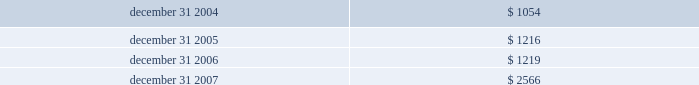Certain options to purchase shares of devon 2019s common stock were excluded from the dilution calculations because the options were antidilutive .
These excluded options totaled 2 million , 3 million and 0.2 million in 2007 , 2006 and 2005 , respectively .
Foreign currency translation adjustments the u.s .
Dollar is the functional currency for devon 2019s consolidated operations except its canadian subsidiaries , which use the canadian dollar as the functional currency .
Therefore , the assets and liabilities of devon 2019s canadian subsidiaries are translated into u.s .
Dollars based on the current exchange rate in effect at the balance sheet dates .
Canadian income and expenses are translated at average rates for the periods presented .
Translation adjustments have no effect on net income and are included in accumulated other comprehensive income in stockholders 2019 equity .
The table presents the balances of devon 2019s cumulative translation adjustments included in accumulated other comprehensive income ( in millions ) . .
Statements of cash flows for purposes of the consolidated statements of cash flows , devon considers all highly liquid investments with original contractual maturities of three months or less to be cash equivalents .
Commitments and contingencies liabilities for loss contingencies arising from claims , assessments , litigation or other sources are recorded when it is probable that a liability has been incurred and the amount can be reasonably estimated .
Liabilities for environmental remediation or restoration claims are recorded when it is probable that obligations have been incurred and the amounts can be reasonably estimated .
Expenditures related to such environmental matters are expensed or capitalized in accordance with devon 2019s accounting policy for property and equipment .
Reference is made to note 8 for a discussion of amounts recorded for these liabilities .
Recently issued accounting standards not yet adopted in december 2007 , the financial accounting standards board ( 201cfasb 201d ) issued statement of financial accounting standards no .
141 ( r ) , business combinations , which replaces statement no .
141 .
Statement no .
141 ( r ) retains the fundamental requirements of statement no .
141 that an acquirer be identified and the acquisition method of accounting ( previously called the purchase method ) be used for all business combinations .
Statement no .
141 ( r ) 2019s scope is broader than that of statement no .
141 , which applied only to business combinations in which control was obtained by transferring consideration .
By applying the acquisition method to all transactions and other events in which one entity obtains control over one or more other businesses , statement no .
141 ( r ) improves the comparability of the information about business combinations provided in financial reports .
Statement no .
141 ( r ) establishes principles and requirements for how an acquirer recognizes and measures identifiable assets acquired , liabilities assumed and any noncontrolling interest in the acquiree , as well as any resulting goodwill .
Statement no .
141 ( r ) applies prospectively to business combinations for which the acquisition date is on or after the beginning of the first annual reporting period beginning on or after december 15 , 2008 .
Devon will evaluate how the new requirements of statement no .
141 ( r ) would impact any business combinations completed in 2009 or thereafter .
In december 2007 , the fasb also issued statement of financial accounting standards no .
160 , noncontrolling interests in consolidated financial statements 2014an amendment of accounting research bulletin no .
51 .
A noncontrolling interest , sometimes called a minority interest , is the portion of equity in a subsidiary not attributable , directly or indirectly , to a parent .
Statement no .
160 establishes accounting and reporting standards for the noncontrolling interest in a subsidiary and for the deconsolidation of a subsidiary .
Under statement no .
160 , noncontrolling interests in a subsidiary must be reported as a component of consolidated equity separate from the parent 2019s equity .
Additionally , the amounts of consolidated net income attributable to both the parent and the noncontrolling interest must be reported separately on the face of the income statement .
Statement no .
160 is effective for fiscal years beginning on or after december 15 , 2008 and earlier adoption is prohibited .
Devon does not expect the adoption of statement no .
160 to have a material impact on its financial statements and related disclosures. .
What was the ratio of the devon 2019s cumulative translation adjustments included in accumulated other comprehensive income for 2005 to 2004? 
Rationale: there was $ 1.2 included in accumulated other comprehensive income of translation adjustments compared to $ 1 in 2004
Computations: (1216 / 1054)
Answer: 1.1537. 